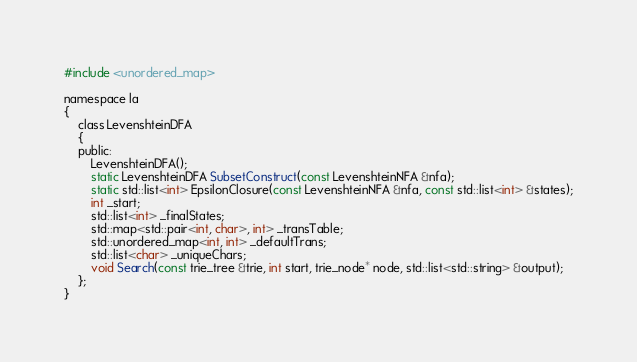<code> <loc_0><loc_0><loc_500><loc_500><_C_>#include <unordered_map>

namespace la
{
    class LevenshteinDFA
    {
    public:
        LevenshteinDFA();
        static LevenshteinDFA SubsetConstruct(const LevenshteinNFA &nfa);
        static std::list<int> EpsilonClosure(const LevenshteinNFA &nfa, const std::list<int> &states);
        int _start;
        std::list<int> _finalStates;
        std::map<std::pair<int, char>, int> _transTable;
        std::unordered_map<int, int> _defaultTrans;
        std::list<char> _uniqueChars;
        void Search(const trie_tree &trie, int start, trie_node* node, std::list<std::string> &output);
    };
}</code> 